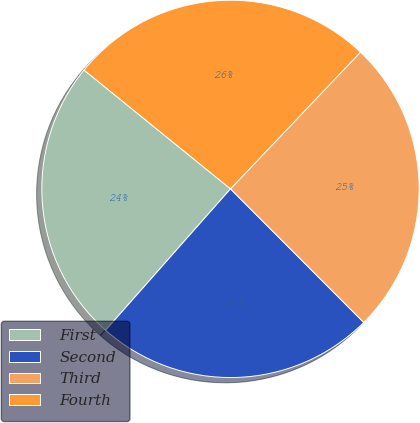Convert chart. <chart><loc_0><loc_0><loc_500><loc_500><pie_chart><fcel>First<fcel>Second<fcel>Third<fcel>Fourth<nl><fcel>24.33%<fcel>24.0%<fcel>25.42%<fcel>26.25%<nl></chart> 